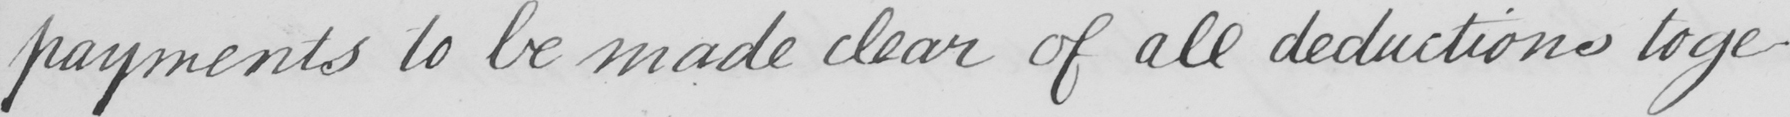Please provide the text content of this handwritten line. payments to be made clear of all deductions toge- 